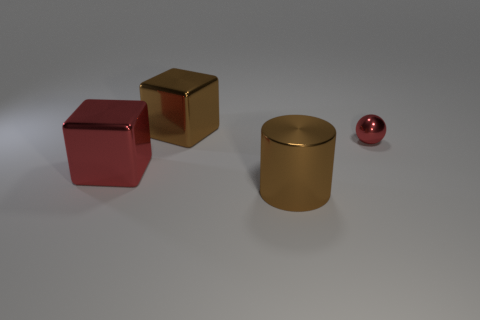Add 2 small blue metallic cubes. How many objects exist? 6 Add 2 tiny spheres. How many tiny spheres exist? 3 Subtract 0 green balls. How many objects are left? 4 Subtract all balls. How many objects are left? 3 Subtract all big metal cylinders. Subtract all metal cylinders. How many objects are left? 2 Add 2 cylinders. How many cylinders are left? 3 